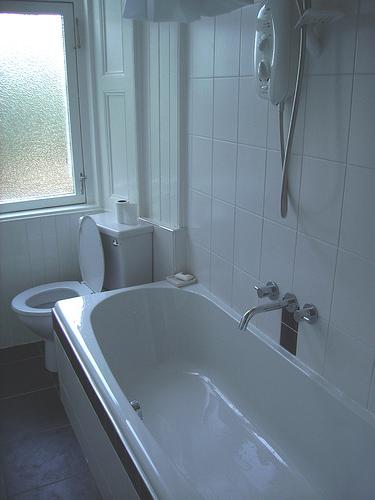What room is this?
Give a very brief answer. Bathroom. Is the bathtub full?
Keep it brief. No. What material is on the wall of the shower?
Answer briefly. Tile. 